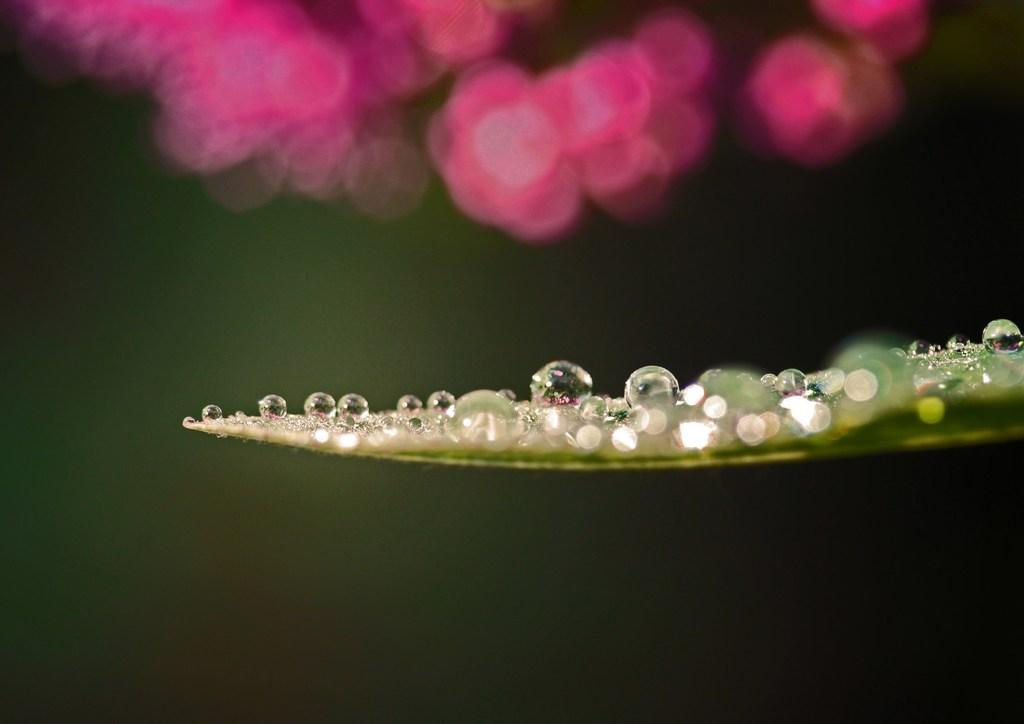What can be seen on the right side of the image? There are water drops on a leaf on the right side of the image. What is the color of the objects at the top of the image? The objects at the top of the image are pink in color. How would you describe the background of the image? The background of the image is dark in color. What brand of toothpaste is being advertised in the image? There is no toothpaste or advertisement present in the image. Is there a bike visible in the image? No, there is no bike present in the image. 